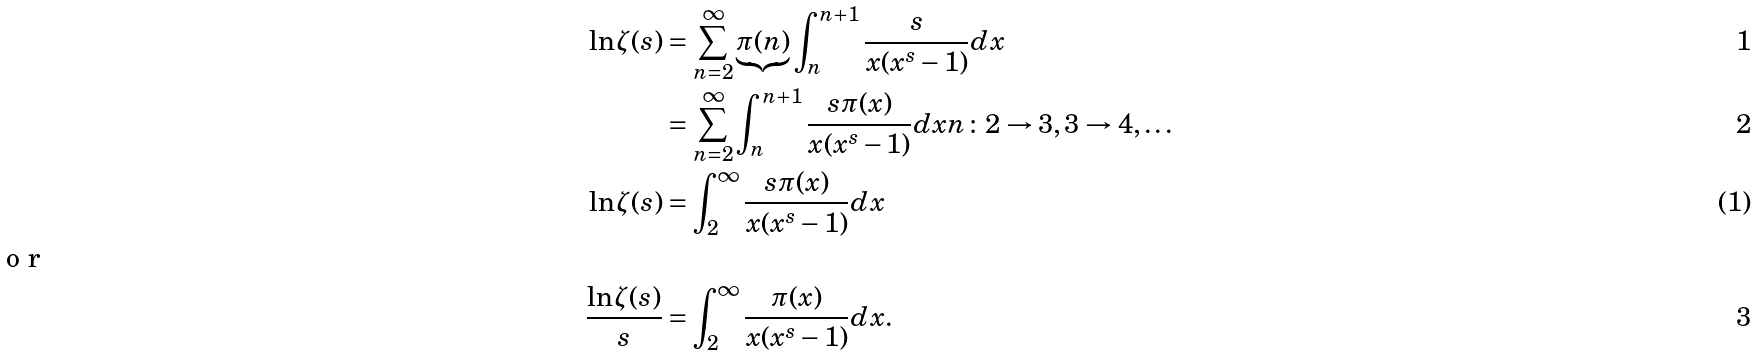<formula> <loc_0><loc_0><loc_500><loc_500>\ln \zeta ( s ) & = \sum _ { n = 2 } ^ { \infty } \underbrace { \pi ( n ) } \int _ { n } ^ { n + 1 } \frac { s } { x ( x ^ { s } - 1 ) } d x \\ & = \sum _ { n = 2 } ^ { \infty } \int _ { n } ^ { n + 1 } \frac { s \pi ( x ) } { x ( x ^ { s } - 1 ) } d x n \colon 2 \rightarrow 3 , 3 \rightarrow 4 , \dots \\ \ln \zeta ( s ) & = \int _ { 2 } ^ { \infty } \frac { s \pi ( x ) } { x ( x ^ { s } - 1 ) } d x \intertext { o r } \frac { \ln \zeta ( s ) } { s } & = \int _ { 2 } ^ { \infty } \frac { \pi ( x ) } { x ( x ^ { s } - 1 ) } d x .</formula> 